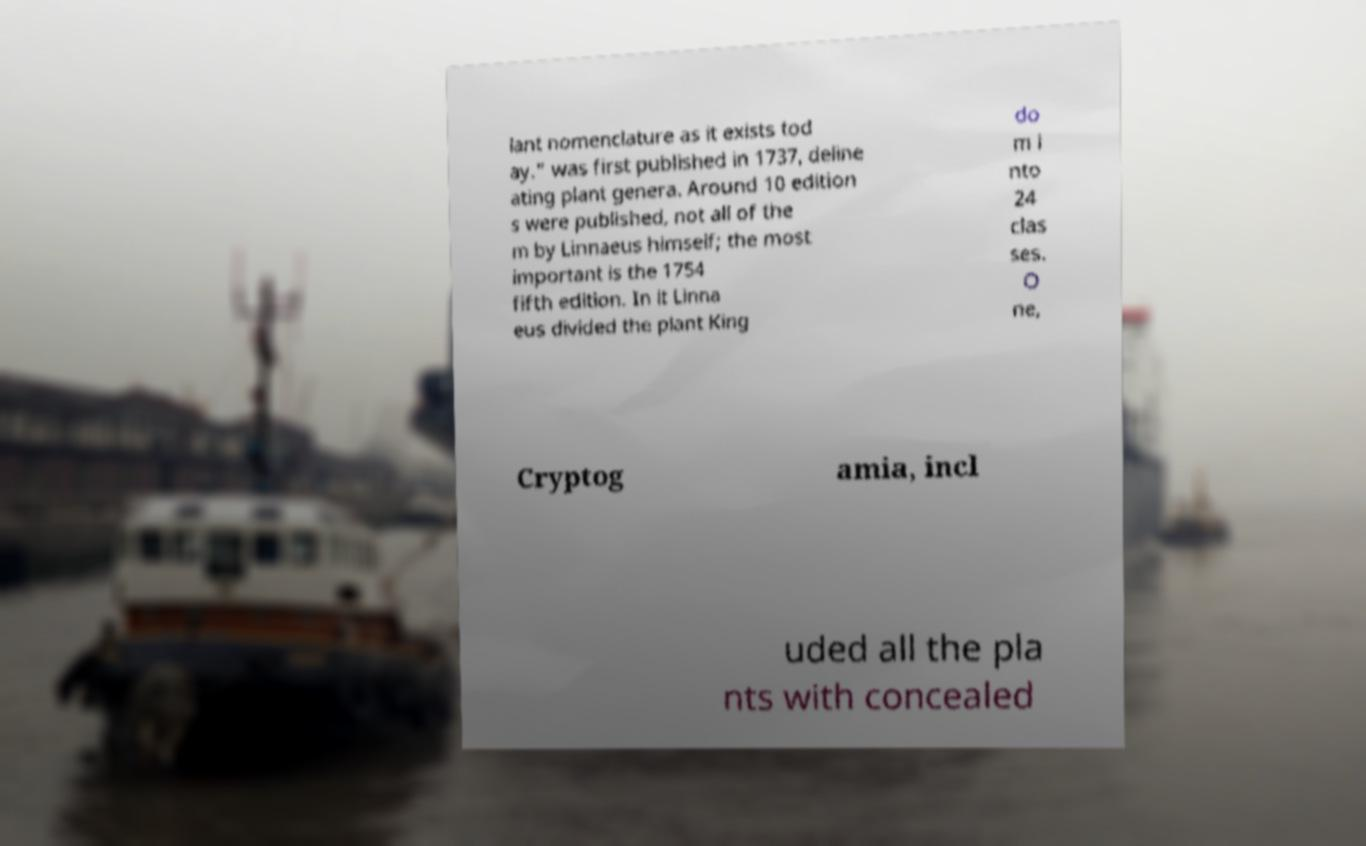Please read and relay the text visible in this image. What does it say? lant nomenclature as it exists tod ay." was first published in 1737, deline ating plant genera. Around 10 edition s were published, not all of the m by Linnaeus himself; the most important is the 1754 fifth edition. In it Linna eus divided the plant King do m i nto 24 clas ses. O ne, Cryptog amia, incl uded all the pla nts with concealed 